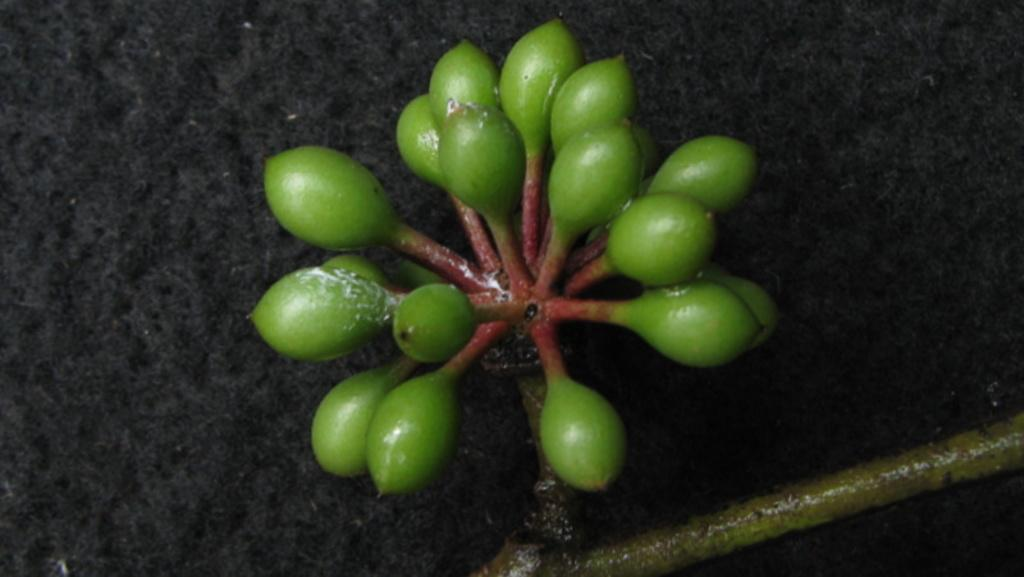What type of living organism can be seen in the image? There is a flower or plant in the image. What is the color of the background in the image? The background of the image is dark. Who is the owner of the wound visible in the image? There is no wound present in the image; it features a flower or plant with a dark background. 